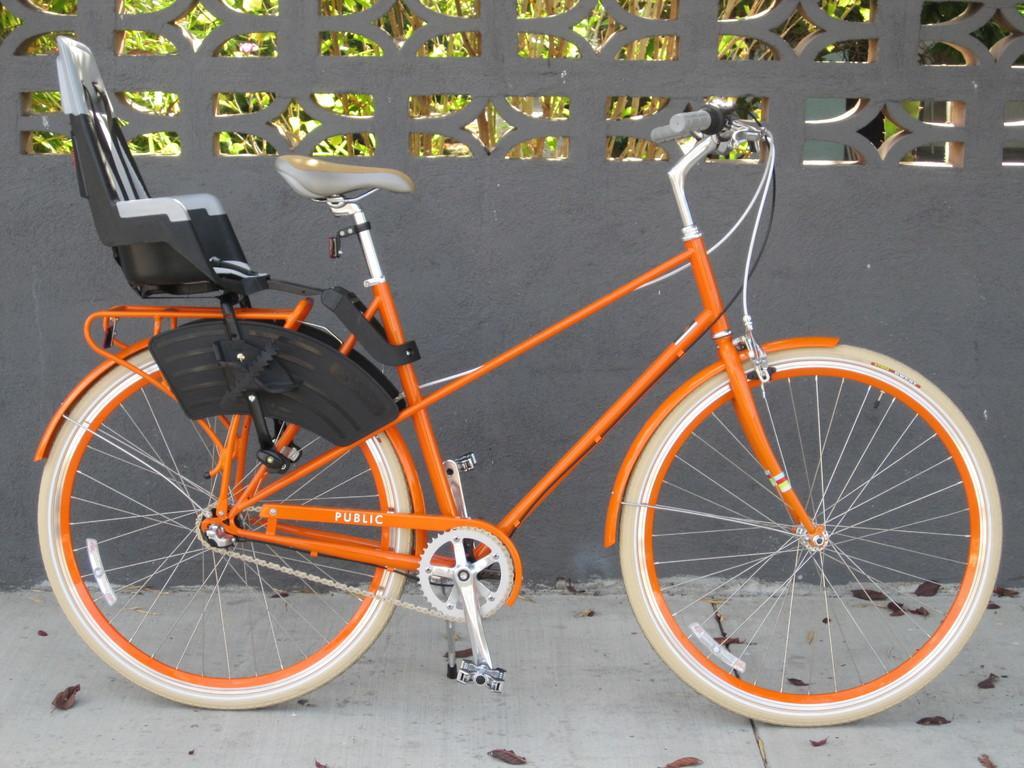How would you summarize this image in a sentence or two? In this picture we can see a bicycle and dried leaves on the ground, fence and in the background we can see trees. 